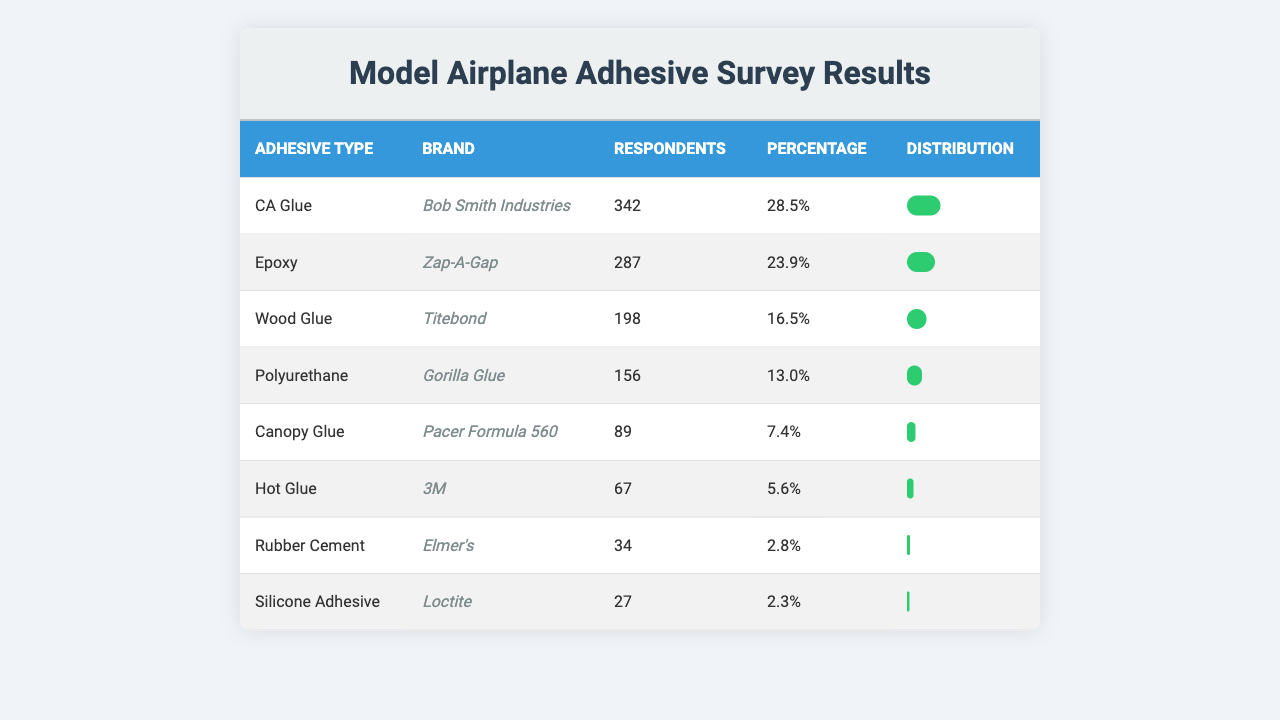What is the most preferred type of adhesive among model airplane hobbyists? The most preferred adhesive type can be found in the table by identifying the adhesive with the highest percentage. It shows that CA Glue has the highest percentage at 28.5%.
Answer: CA Glue How many respondents preferred Epoxy glue? The table indicates that 287 respondents preferred Epoxy glue, which is a specific figure stated next to its brand.
Answer: 287 What percentage of respondents use Hot Glue? The percentage for Hot Glue is provided directly in the table as 5.6%.
Answer: 5.6% Which adhesive has the lowest percentage of usage? To find the adhesive with the lowest usage, we look at the percentages in the table. Rubber Cement has the lowest percentage at 2.8%.
Answer: Rubber Cement What is the combined percentage of Wood Glue and Polyurethane? We simply add the percentages of Wood Glue (16.5%) and Polyurethane (13.0%). The sum is 16.5 + 13.0 = 29.5%.
Answer: 29.5% Is there a significant difference in the number of respondents between CA Glue and Epoxy? CA Glue has 342 respondents and Epoxy has 287 respondents. The difference is 342 - 287 = 55, which is a notable difference.
Answer: Yes What is the average percentage of the top three adhesives? The top three adhesives are CA Glue (28.5%), Epoxy (23.9%), and Wood Glue (16.5%). First sum these percentages: 28.5 + 23.9 + 16.5 = 68.9%. Then divide by 3 (the number of top adhesives) to find the average: 68.9 / 3 = 22.97%.
Answer: 22.97% Which brand of adhesive has more than 200 respondents? Looking at the table, both CA Glue (342) and Epoxy (287) have more than 200 respondents as these figures exceed 200 based on the listed respondents.
Answer: CA Glue and Epoxy How many adhesives have a usage percentage below 10%? The table indicates that Canopy Glue, Hot Glue, Rubber Cement, and Silicone Adhesive all have percentages below 10%: 7.4%, 5.6%, 2.8%, and 2.3%. This totals to four adhesives.
Answer: 4 What is the total number of respondents who prefer Canopy Glue and Hot Glue combined? By adding the number of respondents for Canopy Glue (89) and Hot Glue (67), the total is 89 + 67 = 156.
Answer: 156 